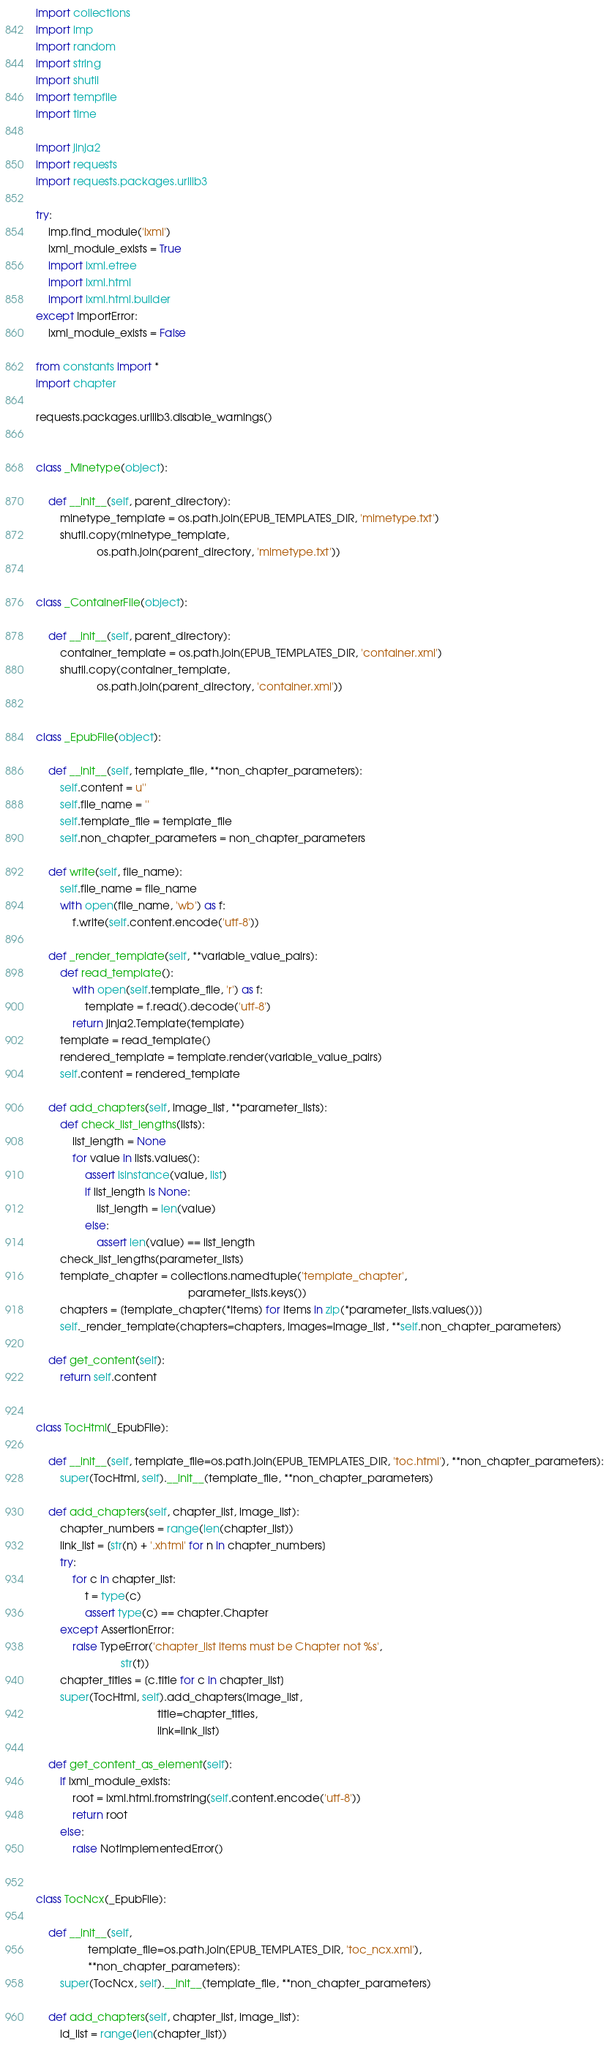Convert code to text. <code><loc_0><loc_0><loc_500><loc_500><_Python_>import collections
import imp
import random
import string
import shutil
import tempfile
import time

import jinja2
import requests
import requests.packages.urllib3

try:
    imp.find_module('lxml')
    lxml_module_exists = True
    import lxml.etree
    import lxml.html
    import lxml.html.builder
except ImportError:
    lxml_module_exists = False

from constants import *
import chapter

requests.packages.urllib3.disable_warnings()


class _Minetype(object):

    def __init__(self, parent_directory):
        minetype_template = os.path.join(EPUB_TEMPLATES_DIR, 'mimetype.txt')
        shutil.copy(minetype_template,
                    os.path.join(parent_directory, 'mimetype.txt'))


class _ContainerFile(object):

    def __init__(self, parent_directory):
        container_template = os.path.join(EPUB_TEMPLATES_DIR, 'container.xml')
        shutil.copy(container_template,
                    os.path.join(parent_directory, 'container.xml'))


class _EpubFile(object):

    def __init__(self, template_file, **non_chapter_parameters):
        self.content = u''
        self.file_name = ''
        self.template_file = template_file
        self.non_chapter_parameters = non_chapter_parameters

    def write(self, file_name):
        self.file_name = file_name
        with open(file_name, 'wb') as f:
            f.write(self.content.encode('utf-8'))

    def _render_template(self, **variable_value_pairs):
        def read_template():
            with open(self.template_file, 'r') as f:
                template = f.read().decode('utf-8')
            return jinja2.Template(template)
        template = read_template()
        rendered_template = template.render(variable_value_pairs)
        self.content = rendered_template

    def add_chapters(self, image_list, **parameter_lists):
        def check_list_lengths(lists):
            list_length = None
            for value in lists.values():
                assert isinstance(value, list)
                if list_length is None:
                    list_length = len(value)
                else:
                    assert len(value) == list_length
        check_list_lengths(parameter_lists)
        template_chapter = collections.namedtuple('template_chapter',
                                                  parameter_lists.keys())
        chapters = [template_chapter(*items) for items in zip(*parameter_lists.values())]
        self._render_template(chapters=chapters, images=image_list, **self.non_chapter_parameters)

    def get_content(self):
        return self.content


class TocHtml(_EpubFile):

    def __init__(self, template_file=os.path.join(EPUB_TEMPLATES_DIR, 'toc.html'), **non_chapter_parameters):
        super(TocHtml, self).__init__(template_file, **non_chapter_parameters)

    def add_chapters(self, chapter_list, image_list):
        chapter_numbers = range(len(chapter_list))
        link_list = [str(n) + '.xhtml' for n in chapter_numbers]
        try:
            for c in chapter_list:
                t = type(c)
                assert type(c) == chapter.Chapter
        except AssertionError:
            raise TypeError('chapter_list items must be Chapter not %s',
                            str(t))
        chapter_titles = [c.title for c in chapter_list]
        super(TocHtml, self).add_chapters(image_list, 
                                        title=chapter_titles, 
                                        link=link_list)

    def get_content_as_element(self):
        if lxml_module_exists:
            root = lxml.html.fromstring(self.content.encode('utf-8'))
            return root
        else:
            raise NotImplementedError()


class TocNcx(_EpubFile):

    def __init__(self,
                 template_file=os.path.join(EPUB_TEMPLATES_DIR, 'toc_ncx.xml'),
                 **non_chapter_parameters):
        super(TocNcx, self).__init__(template_file, **non_chapter_parameters)

    def add_chapters(self, chapter_list, image_list):
        id_list = range(len(chapter_list))</code> 